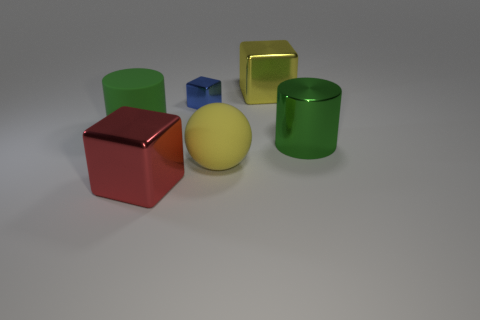There is a sphere that is the same size as the red metal block; what is its color?
Make the answer very short. Yellow. Are there any big metallic blocks of the same color as the large matte sphere?
Provide a short and direct response. Yes. There is a green cylinder that is right of the big green rubber cylinder; does it have the same size as the cube in front of the yellow ball?
Keep it short and to the point. Yes. There is a big thing that is right of the big sphere and in front of the large yellow block; what is its material?
Offer a very short reply. Metal. The thing that is the same color as the rubber cylinder is what size?
Give a very brief answer. Large. What number of other objects are the same size as the yellow metallic object?
Your answer should be very brief. 4. There is a cylinder in front of the big green matte cylinder; what is its material?
Ensure brevity in your answer.  Metal. Do the tiny blue object and the red thing have the same shape?
Your answer should be very brief. Yes. What number of other things are there of the same shape as the green matte object?
Your response must be concise. 1. What color is the large metallic cube behind the large sphere?
Your answer should be compact. Yellow. 